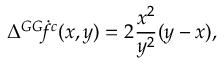<formula> <loc_0><loc_0><loc_500><loc_500>\Delta { ^ { G G } \, \dot { f } ^ { c } } ( x , y ) = 2 \frac { x ^ { 2 } } { y ^ { 2 } } ( y - x ) ,</formula> 